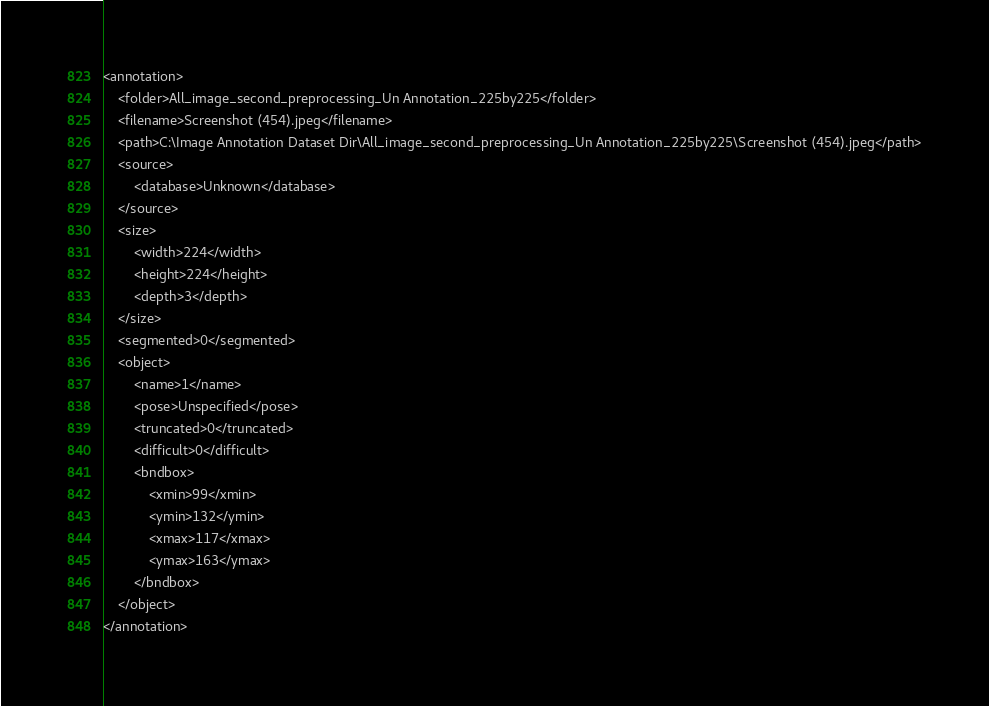Convert code to text. <code><loc_0><loc_0><loc_500><loc_500><_XML_><annotation>
	<folder>All_image_second_preprocessing_Un Annotation_225by225</folder>
	<filename>Screenshot (454).jpeg</filename>
	<path>C:\Image Annotation Dataset Dir\All_image_second_preprocessing_Un Annotation_225by225\Screenshot (454).jpeg</path>
	<source>
		<database>Unknown</database>
	</source>
	<size>
		<width>224</width>
		<height>224</height>
		<depth>3</depth>
	</size>
	<segmented>0</segmented>
	<object>
		<name>1</name>
		<pose>Unspecified</pose>
		<truncated>0</truncated>
		<difficult>0</difficult>
		<bndbox>
			<xmin>99</xmin>
			<ymin>132</ymin>
			<xmax>117</xmax>
			<ymax>163</ymax>
		</bndbox>
	</object>
</annotation>
</code> 